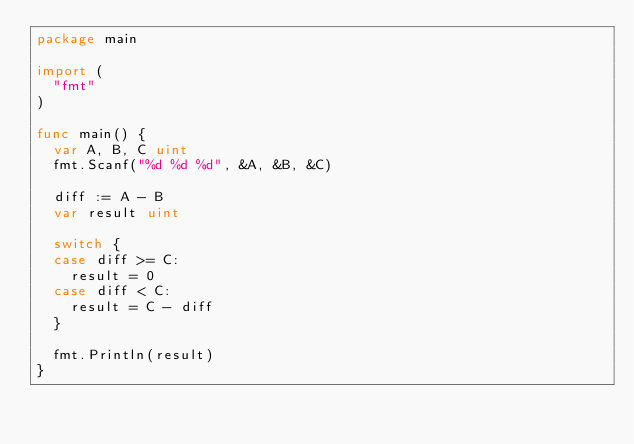<code> <loc_0><loc_0><loc_500><loc_500><_Go_>package main

import (
  "fmt"
)

func main() {
  var A, B, C uint
  fmt.Scanf("%d %d %d", &A, &B, &C)
  
  diff := A - B
  var result uint
  
  switch {
  case diff >= C:
    result = 0
  case diff < C:
    result = C - diff
  }
  
  fmt.Println(result)
}</code> 